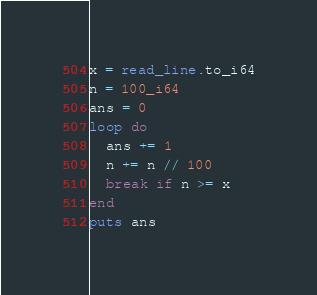Convert code to text. <code><loc_0><loc_0><loc_500><loc_500><_Crystal_>x = read_line.to_i64
n = 100_i64
ans = 0
loop do
  ans += 1
  n += n // 100
  break if n >= x
end
puts ans
</code> 